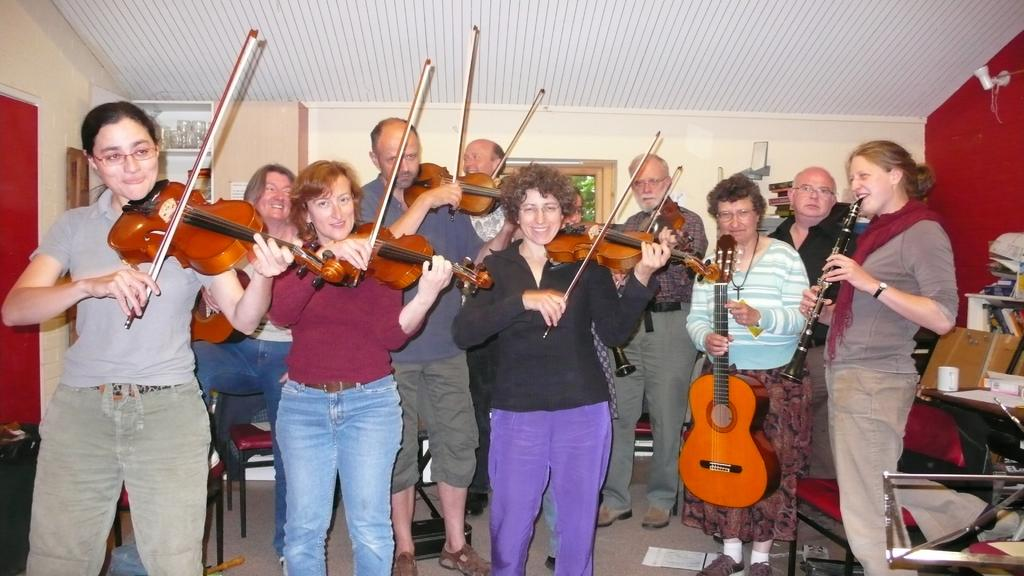How many people are in the image? There is a group of people in the image. What are the people doing in the image? The people are standing and playing violin. What objects can be seen in the background of the image? There is a table, cups, papers, a window, a glass, a cupboard, and a light in the background. Can you see a boat in the image? No, there is no boat present in the image. What type of tail is attached to the violin in the image? There are no tails attached to the violins in the image; violins do not have tails. 